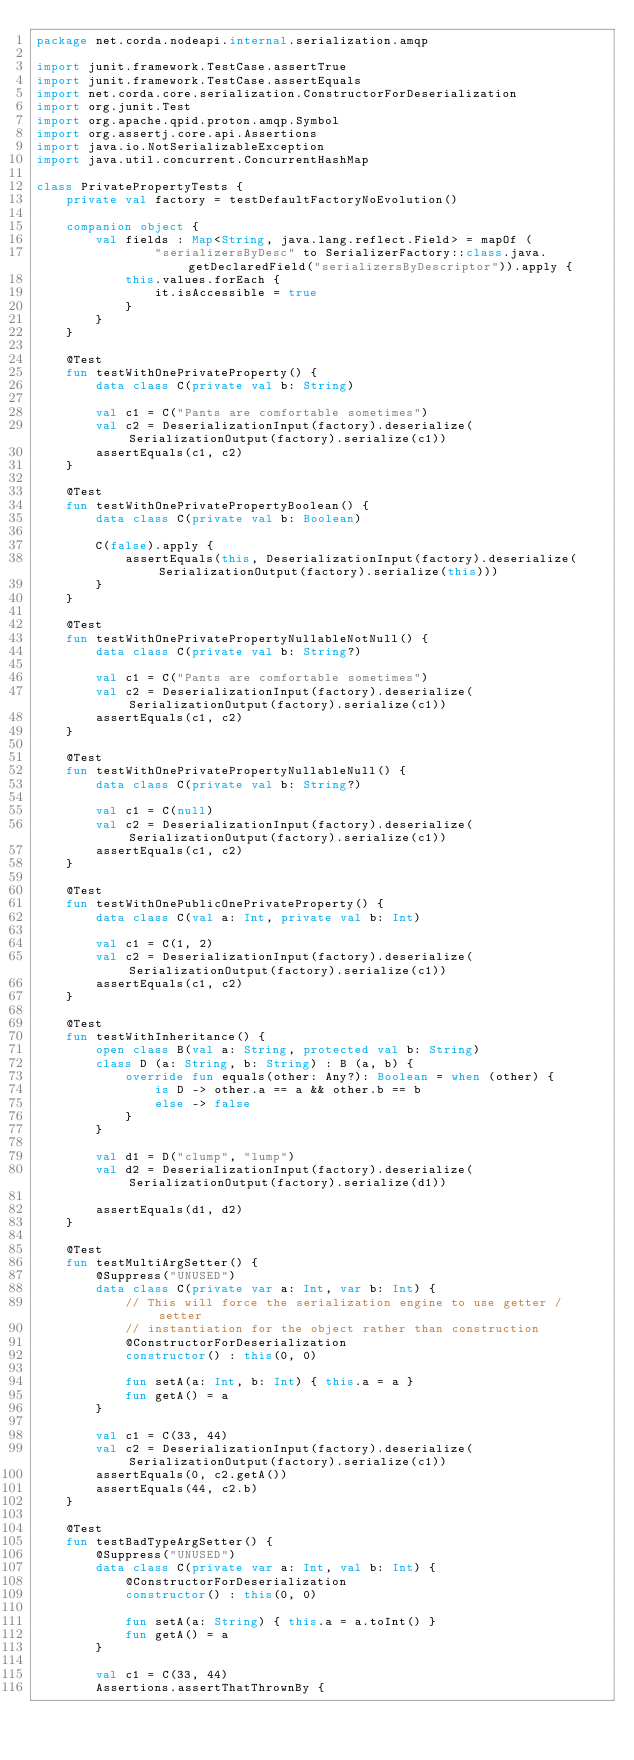Convert code to text. <code><loc_0><loc_0><loc_500><loc_500><_Kotlin_>package net.corda.nodeapi.internal.serialization.amqp

import junit.framework.TestCase.assertTrue
import junit.framework.TestCase.assertEquals
import net.corda.core.serialization.ConstructorForDeserialization
import org.junit.Test
import org.apache.qpid.proton.amqp.Symbol
import org.assertj.core.api.Assertions
import java.io.NotSerializableException
import java.util.concurrent.ConcurrentHashMap

class PrivatePropertyTests {
    private val factory = testDefaultFactoryNoEvolution()

    companion object {
        val fields : Map<String, java.lang.reflect.Field> = mapOf (
                "serializersByDesc" to SerializerFactory::class.java.getDeclaredField("serializersByDescriptor")).apply {
            this.values.forEach {
                it.isAccessible = true
            }
        }
    }

    @Test
    fun testWithOnePrivateProperty() {
        data class C(private val b: String)

        val c1 = C("Pants are comfortable sometimes")
        val c2 = DeserializationInput(factory).deserialize(SerializationOutput(factory).serialize(c1))
        assertEquals(c1, c2)
    }

    @Test
    fun testWithOnePrivatePropertyBoolean() {
        data class C(private val b: Boolean)

        C(false).apply {
            assertEquals(this, DeserializationInput(factory).deserialize(SerializationOutput(factory).serialize(this)))
        }
    }

    @Test
    fun testWithOnePrivatePropertyNullableNotNull() {
        data class C(private val b: String?)

        val c1 = C("Pants are comfortable sometimes")
        val c2 = DeserializationInput(factory).deserialize(SerializationOutput(factory).serialize(c1))
        assertEquals(c1, c2)
    }

    @Test
    fun testWithOnePrivatePropertyNullableNull() {
        data class C(private val b: String?)

        val c1 = C(null)
        val c2 = DeserializationInput(factory).deserialize(SerializationOutput(factory).serialize(c1))
        assertEquals(c1, c2)
    }

    @Test
    fun testWithOnePublicOnePrivateProperty() {
        data class C(val a: Int, private val b: Int)

        val c1 = C(1, 2)
        val c2 = DeserializationInput(factory).deserialize(SerializationOutput(factory).serialize(c1))
        assertEquals(c1, c2)
    }

    @Test
    fun testWithInheritance() {
        open class B(val a: String, protected val b: String)
        class D (a: String, b: String) : B (a, b) {
            override fun equals(other: Any?): Boolean = when (other) {
                is D -> other.a == a && other.b == b
                else -> false
            }
        }

        val d1 = D("clump", "lump")
        val d2 = DeserializationInput(factory).deserialize(SerializationOutput(factory).serialize(d1))

        assertEquals(d1, d2)
    }

    @Test
    fun testMultiArgSetter() {
        @Suppress("UNUSED")
        data class C(private var a: Int, var b: Int) {
            // This will force the serialization engine to use getter / setter
            // instantiation for the object rather than construction
            @ConstructorForDeserialization
            constructor() : this(0, 0)

            fun setA(a: Int, b: Int) { this.a = a }
            fun getA() = a
        }

        val c1 = C(33, 44)
        val c2 = DeserializationInput(factory).deserialize(SerializationOutput(factory).serialize(c1))
        assertEquals(0, c2.getA())
        assertEquals(44, c2.b)
    }

    @Test
    fun testBadTypeArgSetter() {
        @Suppress("UNUSED")
        data class C(private var a: Int, val b: Int) {
            @ConstructorForDeserialization
            constructor() : this(0, 0)

            fun setA(a: String) { this.a = a.toInt() }
            fun getA() = a
        }

        val c1 = C(33, 44)
        Assertions.assertThatThrownBy {</code> 